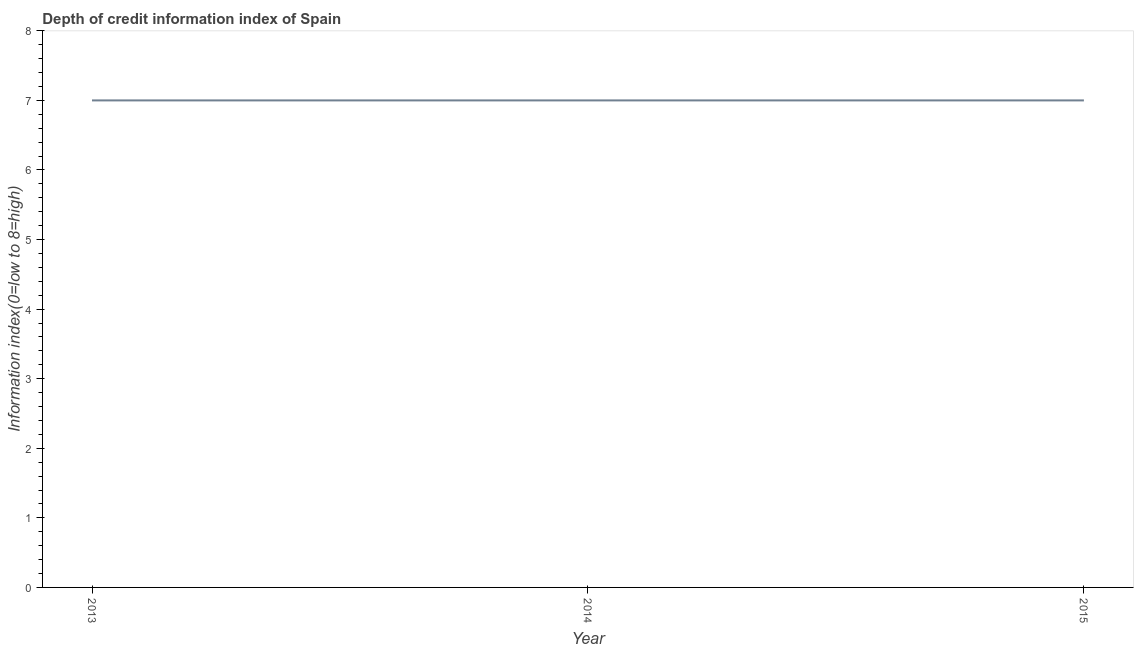What is the depth of credit information index in 2013?
Your answer should be very brief. 7. Across all years, what is the maximum depth of credit information index?
Your answer should be compact. 7. Across all years, what is the minimum depth of credit information index?
Offer a very short reply. 7. In which year was the depth of credit information index maximum?
Your response must be concise. 2013. In which year was the depth of credit information index minimum?
Your answer should be compact. 2013. What is the sum of the depth of credit information index?
Provide a succinct answer. 21. What is the difference between the depth of credit information index in 2013 and 2015?
Your response must be concise. 0. What is the average depth of credit information index per year?
Offer a very short reply. 7. What is the median depth of credit information index?
Make the answer very short. 7. Is the sum of the depth of credit information index in 2013 and 2015 greater than the maximum depth of credit information index across all years?
Ensure brevity in your answer.  Yes. In how many years, is the depth of credit information index greater than the average depth of credit information index taken over all years?
Offer a very short reply. 0. How many lines are there?
Your answer should be compact. 1. Are the values on the major ticks of Y-axis written in scientific E-notation?
Ensure brevity in your answer.  No. What is the title of the graph?
Give a very brief answer. Depth of credit information index of Spain. What is the label or title of the X-axis?
Give a very brief answer. Year. What is the label or title of the Y-axis?
Offer a terse response. Information index(0=low to 8=high). What is the Information index(0=low to 8=high) of 2013?
Provide a succinct answer. 7. What is the difference between the Information index(0=low to 8=high) in 2014 and 2015?
Make the answer very short. 0. What is the ratio of the Information index(0=low to 8=high) in 2013 to that in 2014?
Offer a very short reply. 1. What is the ratio of the Information index(0=low to 8=high) in 2013 to that in 2015?
Make the answer very short. 1. 